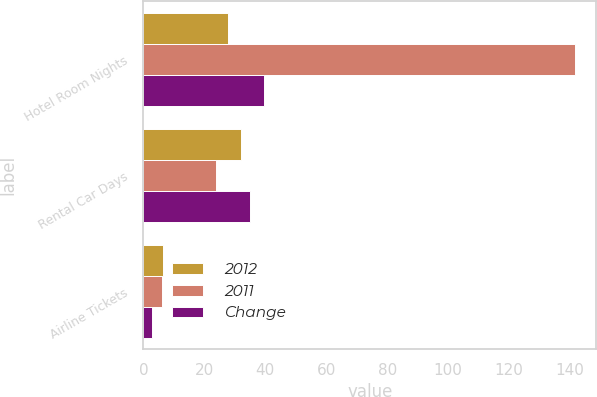<chart> <loc_0><loc_0><loc_500><loc_500><stacked_bar_chart><ecel><fcel>Hotel Room Nights<fcel>Rental Car Days<fcel>Airline Tickets<nl><fcel>2012<fcel>27.9<fcel>32<fcel>6.4<nl><fcel>2011<fcel>141.6<fcel>23.8<fcel>6.2<nl><fcel>Change<fcel>39.5<fcel>34.9<fcel>2.7<nl></chart> 